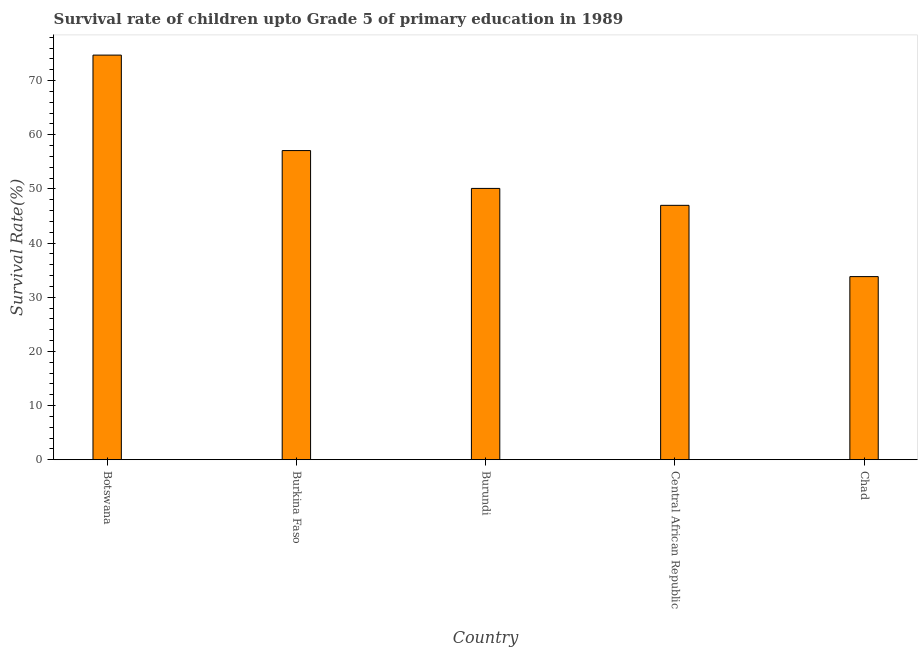Does the graph contain any zero values?
Keep it short and to the point. No. Does the graph contain grids?
Provide a short and direct response. No. What is the title of the graph?
Keep it short and to the point. Survival rate of children upto Grade 5 of primary education in 1989 . What is the label or title of the X-axis?
Offer a terse response. Country. What is the label or title of the Y-axis?
Provide a short and direct response. Survival Rate(%). What is the survival rate in Burundi?
Offer a very short reply. 50.08. Across all countries, what is the maximum survival rate?
Provide a succinct answer. 74.69. Across all countries, what is the minimum survival rate?
Provide a short and direct response. 33.8. In which country was the survival rate maximum?
Offer a terse response. Botswana. In which country was the survival rate minimum?
Make the answer very short. Chad. What is the sum of the survival rate?
Keep it short and to the point. 262.61. What is the difference between the survival rate in Botswana and Central African Republic?
Offer a terse response. 27.73. What is the average survival rate per country?
Your answer should be compact. 52.52. What is the median survival rate?
Provide a succinct answer. 50.08. What is the ratio of the survival rate in Burkina Faso to that in Central African Republic?
Provide a short and direct response. 1.22. Is the survival rate in Burkina Faso less than that in Central African Republic?
Provide a short and direct response. No. Is the difference between the survival rate in Botswana and Burkina Faso greater than the difference between any two countries?
Your answer should be compact. No. What is the difference between the highest and the second highest survival rate?
Your answer should be compact. 17.62. What is the difference between the highest and the lowest survival rate?
Keep it short and to the point. 40.89. How many bars are there?
Offer a terse response. 5. Are all the bars in the graph horizontal?
Keep it short and to the point. No. Are the values on the major ticks of Y-axis written in scientific E-notation?
Make the answer very short. No. What is the Survival Rate(%) in Botswana?
Offer a terse response. 74.69. What is the Survival Rate(%) in Burkina Faso?
Provide a succinct answer. 57.07. What is the Survival Rate(%) of Burundi?
Make the answer very short. 50.08. What is the Survival Rate(%) in Central African Republic?
Provide a succinct answer. 46.96. What is the Survival Rate(%) in Chad?
Offer a very short reply. 33.8. What is the difference between the Survival Rate(%) in Botswana and Burkina Faso?
Your answer should be very brief. 17.62. What is the difference between the Survival Rate(%) in Botswana and Burundi?
Provide a succinct answer. 24.61. What is the difference between the Survival Rate(%) in Botswana and Central African Republic?
Ensure brevity in your answer.  27.73. What is the difference between the Survival Rate(%) in Botswana and Chad?
Keep it short and to the point. 40.89. What is the difference between the Survival Rate(%) in Burkina Faso and Burundi?
Make the answer very short. 6.99. What is the difference between the Survival Rate(%) in Burkina Faso and Central African Republic?
Provide a succinct answer. 10.11. What is the difference between the Survival Rate(%) in Burkina Faso and Chad?
Offer a very short reply. 23.27. What is the difference between the Survival Rate(%) in Burundi and Central African Republic?
Provide a succinct answer. 3.12. What is the difference between the Survival Rate(%) in Burundi and Chad?
Give a very brief answer. 16.28. What is the difference between the Survival Rate(%) in Central African Republic and Chad?
Give a very brief answer. 13.16. What is the ratio of the Survival Rate(%) in Botswana to that in Burkina Faso?
Ensure brevity in your answer.  1.31. What is the ratio of the Survival Rate(%) in Botswana to that in Burundi?
Provide a succinct answer. 1.49. What is the ratio of the Survival Rate(%) in Botswana to that in Central African Republic?
Offer a very short reply. 1.59. What is the ratio of the Survival Rate(%) in Botswana to that in Chad?
Your answer should be very brief. 2.21. What is the ratio of the Survival Rate(%) in Burkina Faso to that in Burundi?
Offer a very short reply. 1.14. What is the ratio of the Survival Rate(%) in Burkina Faso to that in Central African Republic?
Offer a terse response. 1.22. What is the ratio of the Survival Rate(%) in Burkina Faso to that in Chad?
Provide a short and direct response. 1.69. What is the ratio of the Survival Rate(%) in Burundi to that in Central African Republic?
Offer a terse response. 1.07. What is the ratio of the Survival Rate(%) in Burundi to that in Chad?
Provide a short and direct response. 1.48. What is the ratio of the Survival Rate(%) in Central African Republic to that in Chad?
Provide a succinct answer. 1.39. 